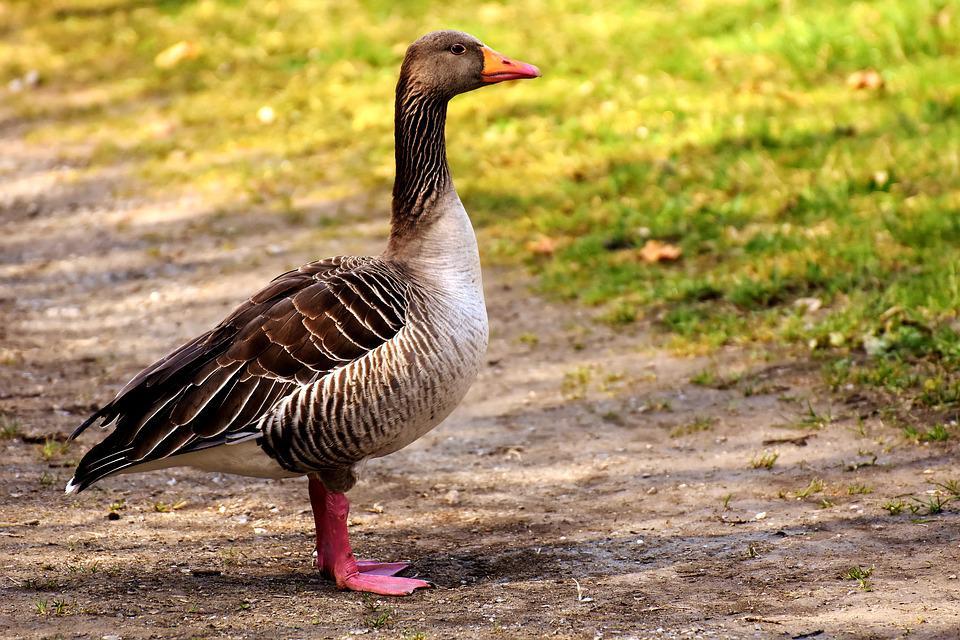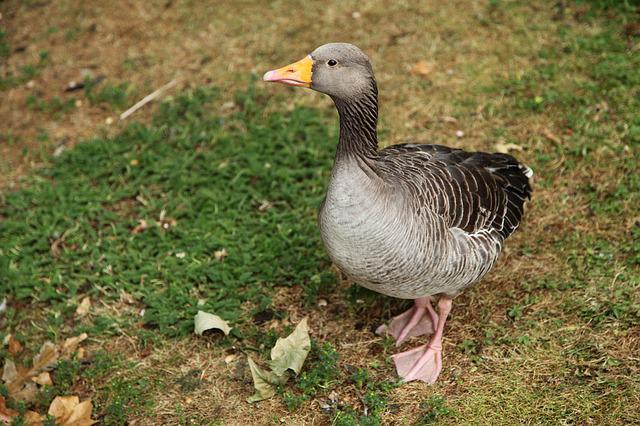The first image is the image on the left, the second image is the image on the right. Considering the images on both sides, is "There are two geese" valid? Answer yes or no. Yes. 